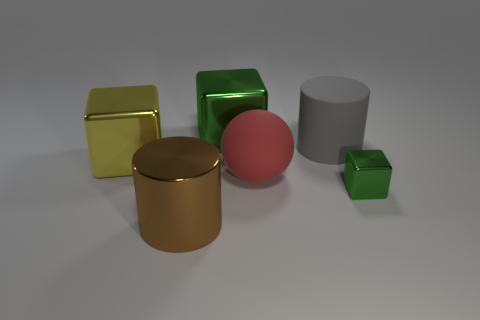Do the large metallic block that is to the right of the metallic cylinder and the cube in front of the big red ball have the same color?
Provide a succinct answer. Yes. There is a cylinder behind the cylinder on the left side of the shiny thing that is behind the large yellow object; what is it made of?
Ensure brevity in your answer.  Rubber. Is there a green rubber cube that has the same size as the ball?
Make the answer very short. No. What is the material of the green block that is the same size as the red object?
Make the answer very short. Metal. What shape is the green thing left of the large red object?
Your answer should be very brief. Cube. Is the material of the green object that is behind the ball the same as the cylinder that is behind the big brown cylinder?
Keep it short and to the point. No. What number of big green things have the same shape as the small metal object?
Your response must be concise. 1. There is a big object that is the same color as the tiny shiny block; what material is it?
Make the answer very short. Metal. How many objects are large yellow metal cubes or large green cubes behind the red ball?
Provide a succinct answer. 2. What is the material of the large green thing?
Offer a very short reply. Metal. 